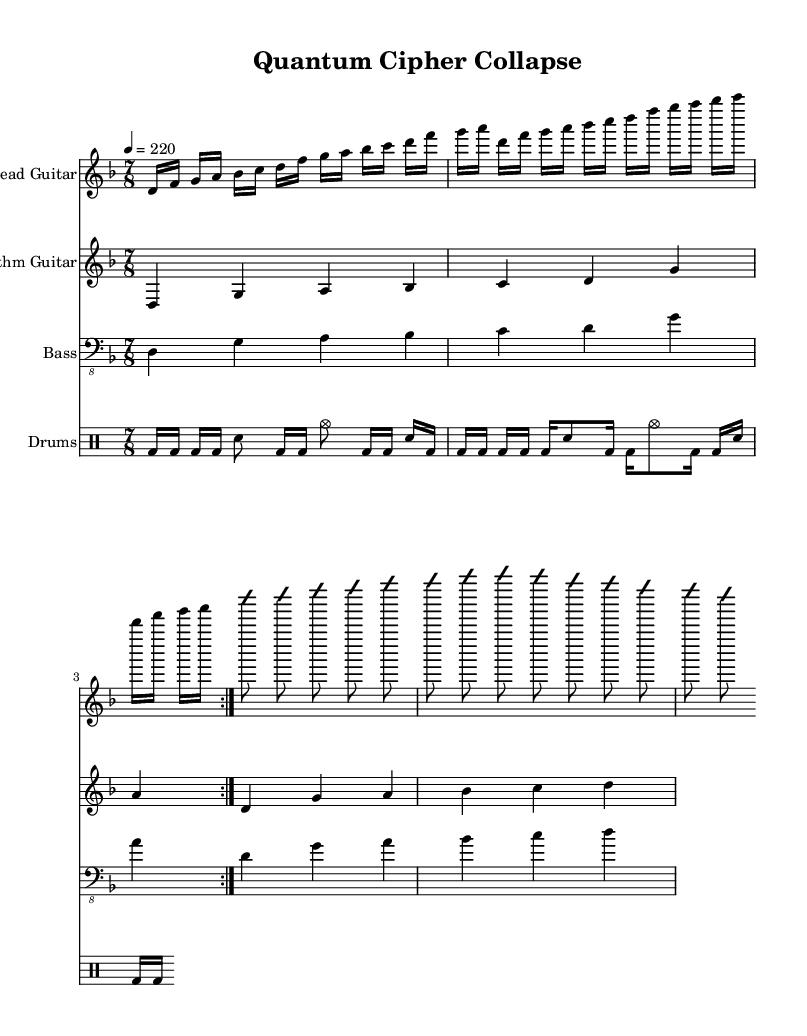What is the key signature of this music? The key signature is indicated at the beginning of the score. "D minor" is shown, meaning there is one flat (B flat).
Answer: D minor What is the time signature of this music? The time signature is shown at the beginning of the score. "7/8" indicates there are seven eighth notes in each measure.
Answer: 7/8 What is the tempo marking for this piece? The tempo marking is set at the beginning of the score. "4 = 220" means that there are 220 beats per minute.
Answer: 220 How many measures are in the lead guitar section? The lead guitar section repeats its main riff twice. Each repeat indicates 4 measures, totaling 8 measures in this section.
Answer: 8 What tuning is used for the lead and rhythm guitars? The score specifies the tuning in the staff settings as "guitar-drop-d-tuning," meaning the lowest string is tuned to D.
Answer: Drop D What type of scale is hinted for the solo in the lead guitar? In the lead guitar solo hint, the notes suggest the D harmonic minor scale, which is commonly used in metal music for its dramatic sound.
Answer: D harmonic minor How is the drum rhythm primarily structured in this piece? The drum pattern comprises both bass drum and snare hits, showing a consistent rhythm that emphasizes the heavy feel typical of technical death metal.
Answer: Consistent heavy rhythm 